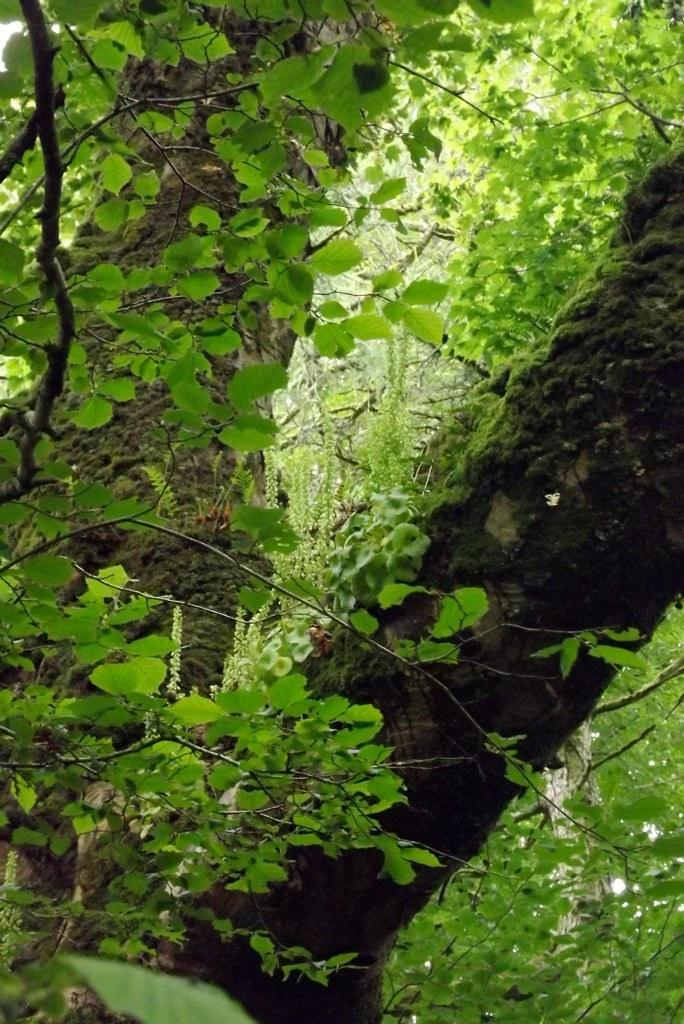What type of vegetation can be seen in the image? There are trees in the image. What is the color of the leaves on the trees? The trees have green leaves. Can you see a horn on any of the trees in the image? There is no horn present on any of the trees in the image. 